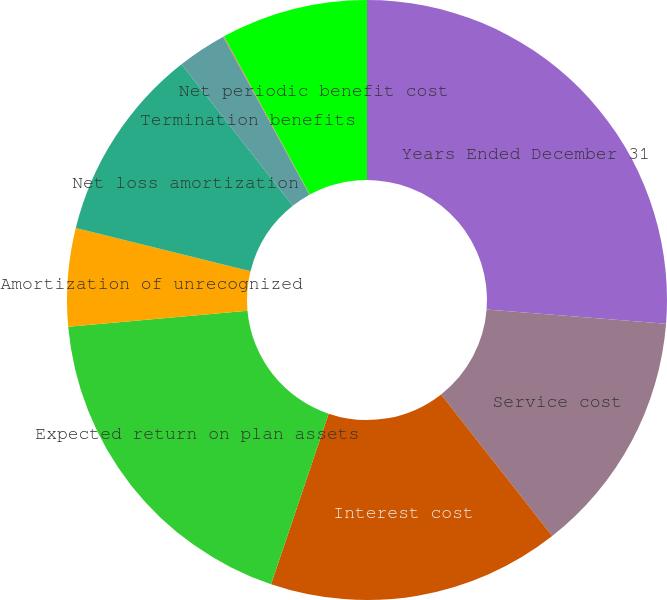<chart> <loc_0><loc_0><loc_500><loc_500><pie_chart><fcel>Years Ended December 31<fcel>Service cost<fcel>Interest cost<fcel>Expected return on plan assets<fcel>Amortization of unrecognized<fcel>Net loss amortization<fcel>Termination benefits<fcel>Curtailments<fcel>Net periodic benefit cost<nl><fcel>26.26%<fcel>13.15%<fcel>15.77%<fcel>18.4%<fcel>5.28%<fcel>10.53%<fcel>2.66%<fcel>0.04%<fcel>7.91%<nl></chart> 